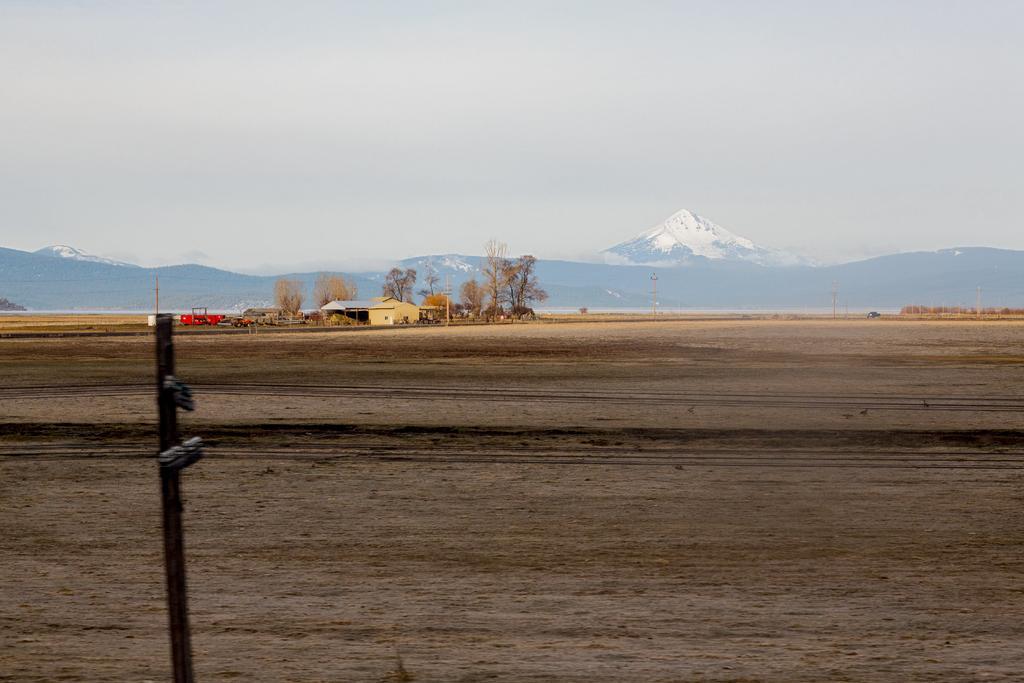How would you summarize this image in a sentence or two? In this image I can see few houses, trees, poles, red color object and mountains. The sky is in blue and white color. 